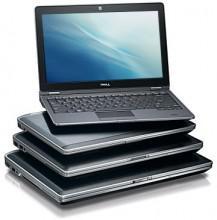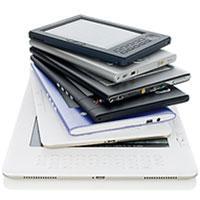The first image is the image on the left, the second image is the image on the right. Given the left and right images, does the statement "An open laptop is sitting on a stack of at least three rectangular items in the left image." hold true? Answer yes or no. Yes. The first image is the image on the left, the second image is the image on the right. Considering the images on both sides, is "Electronic devices are stacked upon each other in each of the images." valid? Answer yes or no. Yes. 